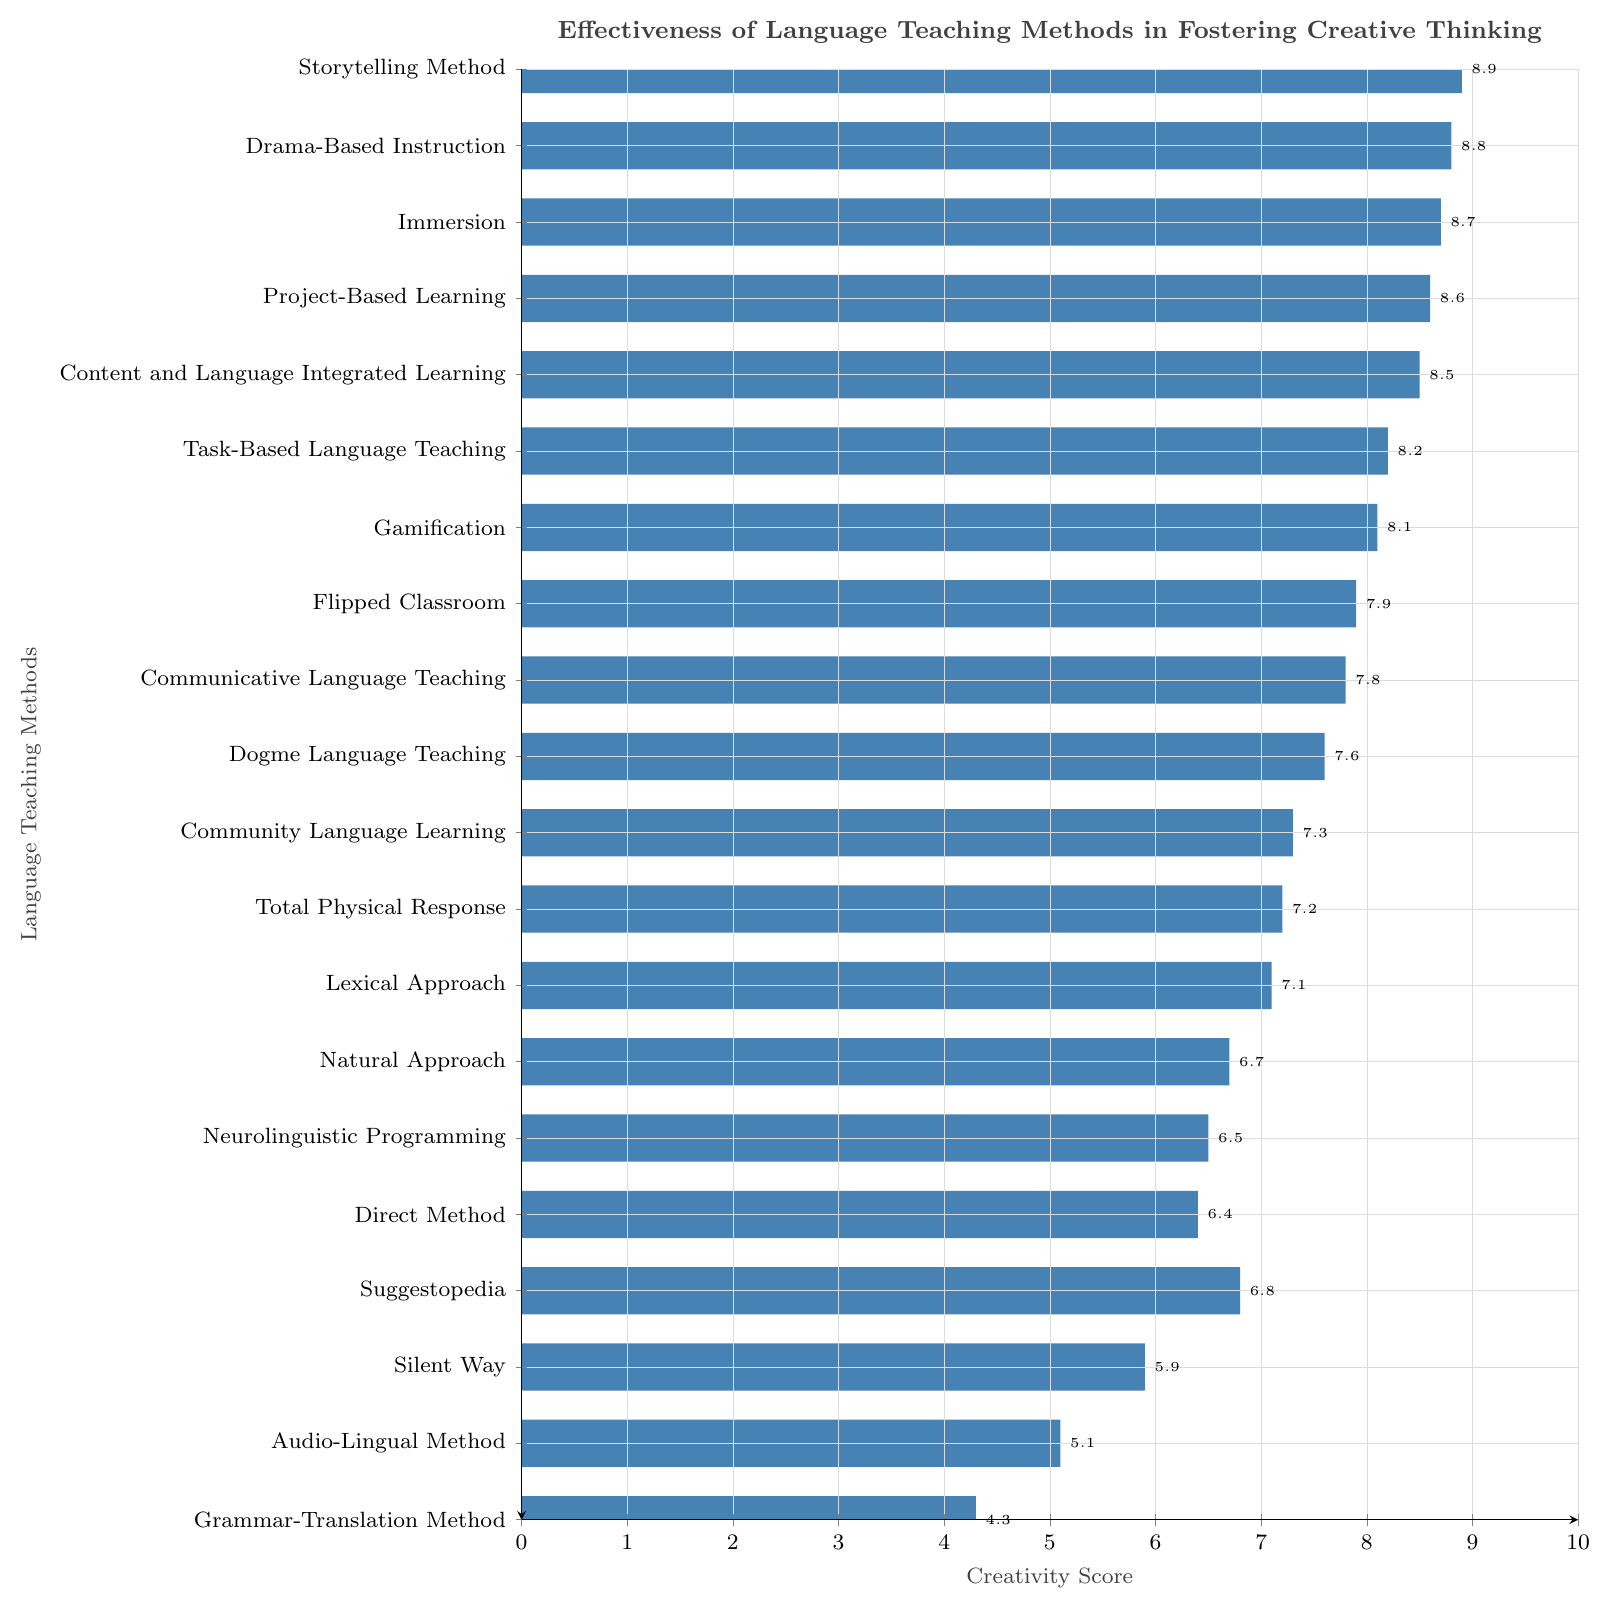What's the effectiveness of the Communicative Language Teaching method in fostering creative thinking? The Creativity Score for the Communicative Language Teaching method can be directly read from the data: it is represented by a bar length of 7.8 units.
Answer: 7.8 Which method has the highest creativity score? The Storytelling Method has the highest creativity score, as indicated by the tallest bar on the graph, with a value of 8.9.
Answer: Storytelling Method How does the Audio-Lingual Method compare with the Natural Approach in terms of creativity score? The Audio-Lingual Method has a Creativity Score of 5.1, while the Natural Approach has a Creativity Score of 6.7. This means the Natural Approach has a higher Creativity Score.
Answer: The Natural Approach has a higher score What is the median value of the Creativity Score for the listed methods? To find the median, we first arrange the Creativity Scores in ascending order: 4.3, 5.1, 5.9, 6.4, 6.5, 6.7, 6.8, 7.1, 7.2, 7.3, 7.6, 7.8, 7.9, 8.1, 8.2, 8.5, 8.6, 8.7, 8.8, 8.9. With 20 scores, the median is the average of the 10th and 11th values: (7.3 + 7.6) / 2.
Answer: 7.45 Which method has a bar color different from the others? All bars representing the various language teaching methods are uniformly colored in the same bar color throughout the chart.
Answer: None What's the average Creativity Score of methods scoring above 8? Methods scoring above 8 include Project-Based Learning (8.6), Drama-Based Instruction (8.8), Immersion (8.7), and Storytelling Method (8.9). Their average score is (8.6 + 8.8 + 8.7 + 8.9) / 4.
Answer: 8.75 Is there any method with a Creativity Score lower than 5? If so, which one? The Grammar-Translation Method has a Creativity Score of 4.3, which is less than 5.
Answer: Grammar-Translation Method What is the difference in Creativity Scores between the Direct Method and the Suggestopedia method? The Creativity Score for the Direct Method is 6.4, and for Suggestopedia, it is 6.8. The difference is 6.8 - 6.4.
Answer: 0.4 